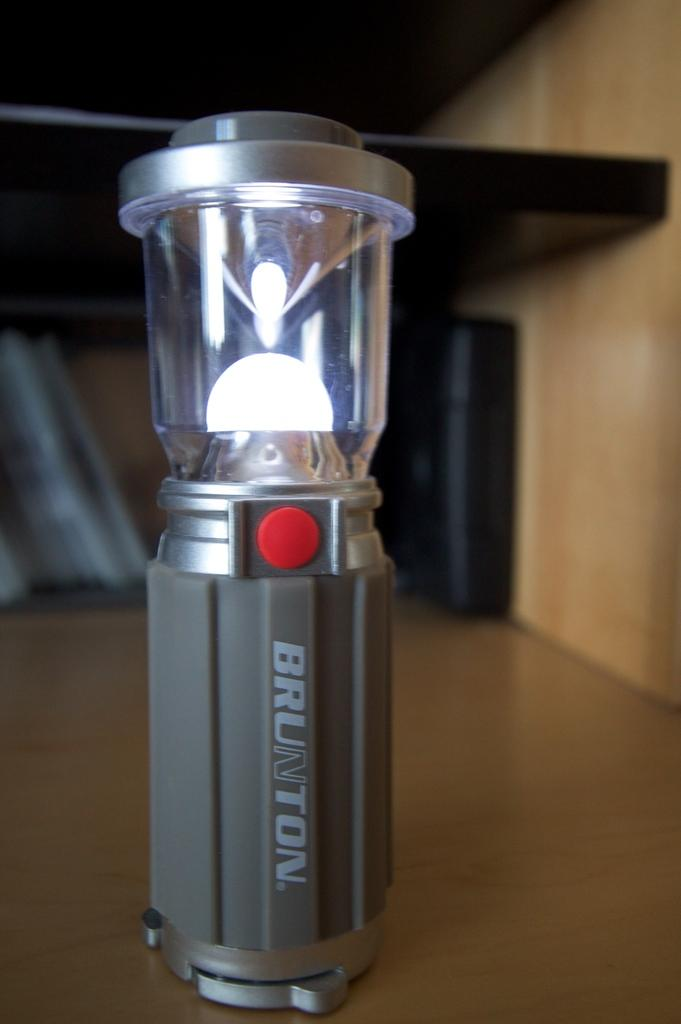<image>
Give a short and clear explanation of the subsequent image. A light with a red button that says Brunton 